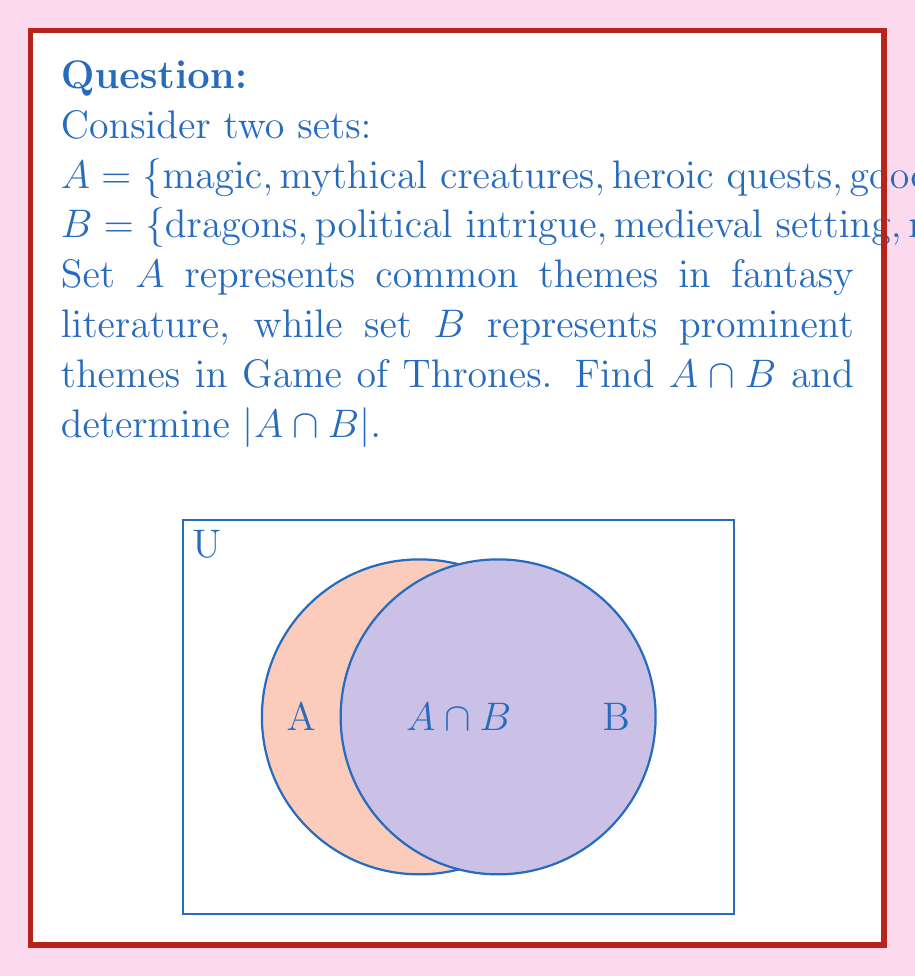Provide a solution to this math problem. To solve this problem, we need to follow these steps:

1) Identify the elements that are present in both set $A$ and set $B$. These elements form the intersection of the two sets.

2) The intersection $A \cap B$ is defined as:
   $A \cap B = \{x : x \in A \text{ and } x \in B\}$

3) Comparing the elements of both sets:
   - "magic" is in both $A$ and $B$
   - "medieval setting" is in both $A$ and $B$
   - "supernatural elements" is in both $A$ and $B$

4) Therefore, $A \cap B = \{\text{magic}, \text{medieval setting}, \text{supernatural elements}\}$

5) To find $|A \cap B|$, we simply count the number of elements in the intersection.
   $|A \cap B| = 3$

This intersection reveals that Game of Thrones shares several key themes with traditional fantasy literature, particularly the use of magic, a medieval setting, and supernatural elements. These common themes help to ground Game of Thrones in the fantasy genre while it explores other themes that may be less typical of traditional fantasy.
Answer: $A \cap B = \{\text{magic}, \text{medieval setting}, \text{supernatural elements}\}$; $|A \cap B| = 3$ 